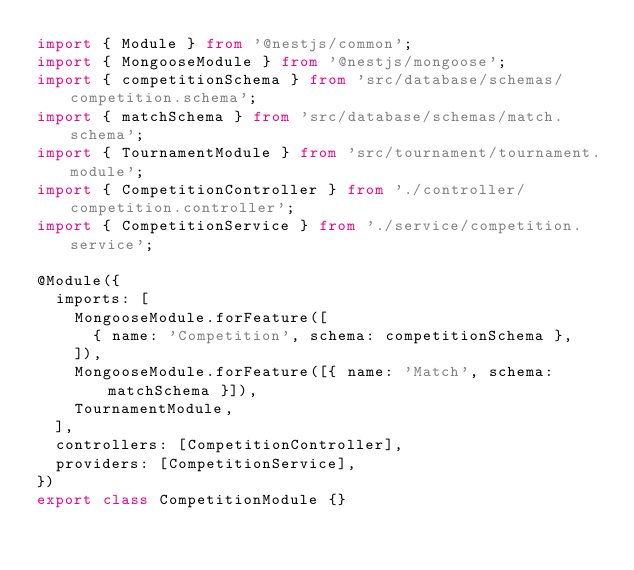Convert code to text. <code><loc_0><loc_0><loc_500><loc_500><_TypeScript_>import { Module } from '@nestjs/common';
import { MongooseModule } from '@nestjs/mongoose';
import { competitionSchema } from 'src/database/schemas/competition.schema';
import { matchSchema } from 'src/database/schemas/match.schema';
import { TournamentModule } from 'src/tournament/tournament.module';
import { CompetitionController } from './controller/competition.controller';
import { CompetitionService } from './service/competition.service';

@Module({
  imports: [
    MongooseModule.forFeature([
      { name: 'Competition', schema: competitionSchema },
    ]),
    MongooseModule.forFeature([{ name: 'Match', schema: matchSchema }]),
    TournamentModule,
  ],
  controllers: [CompetitionController],
  providers: [CompetitionService],
})
export class CompetitionModule {}
</code> 